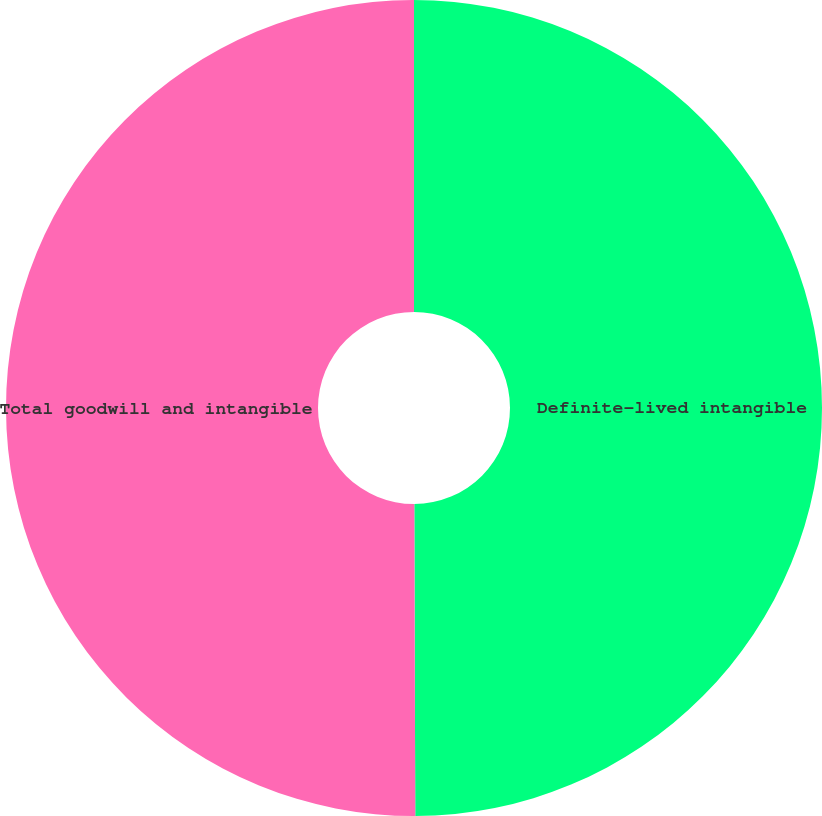Convert chart to OTSL. <chart><loc_0><loc_0><loc_500><loc_500><pie_chart><fcel>Definite-lived intangible<fcel>Total goodwill and intangible<nl><fcel>49.95%<fcel>50.05%<nl></chart> 